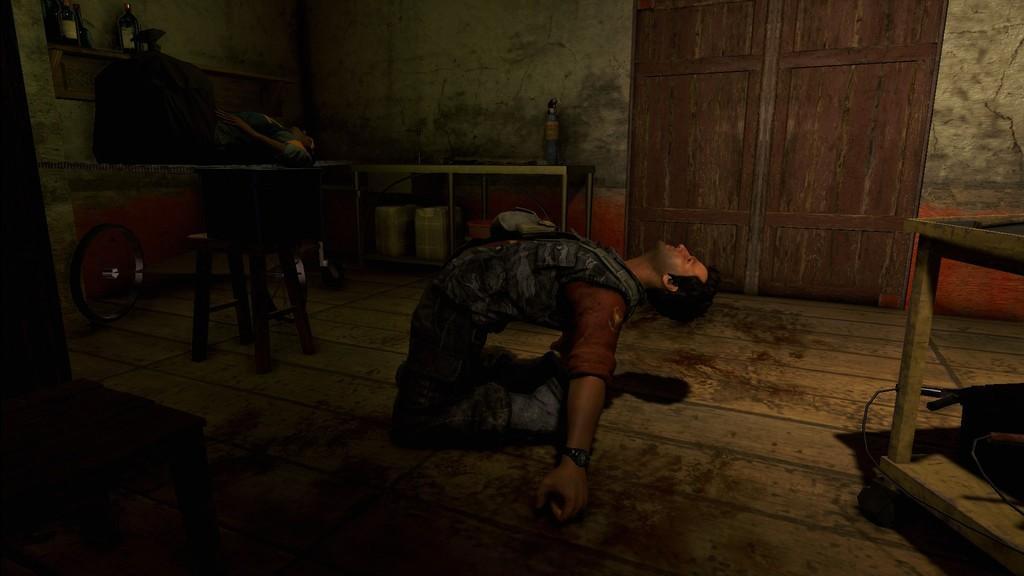Please provide a concise description of this image. In the foreground of this animated image, there is a man kneeling down on the floor and also a man laying on a table. We can also see wheels, cans, tables, few objects, fire extinguisher, bottles, wall and a door. 